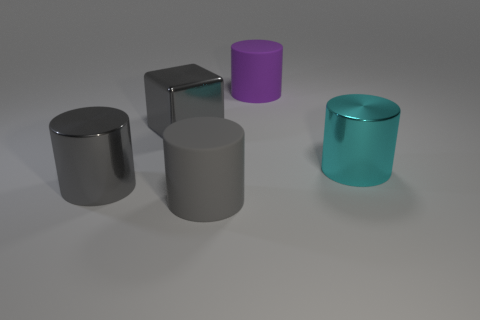Add 1 purple matte cylinders. How many objects exist? 6 Subtract all cubes. How many objects are left? 4 Subtract 0 brown cylinders. How many objects are left? 5 Subtract all big green objects. Subtract all big gray metal objects. How many objects are left? 3 Add 3 metallic objects. How many metallic objects are left? 6 Add 2 rubber things. How many rubber things exist? 4 